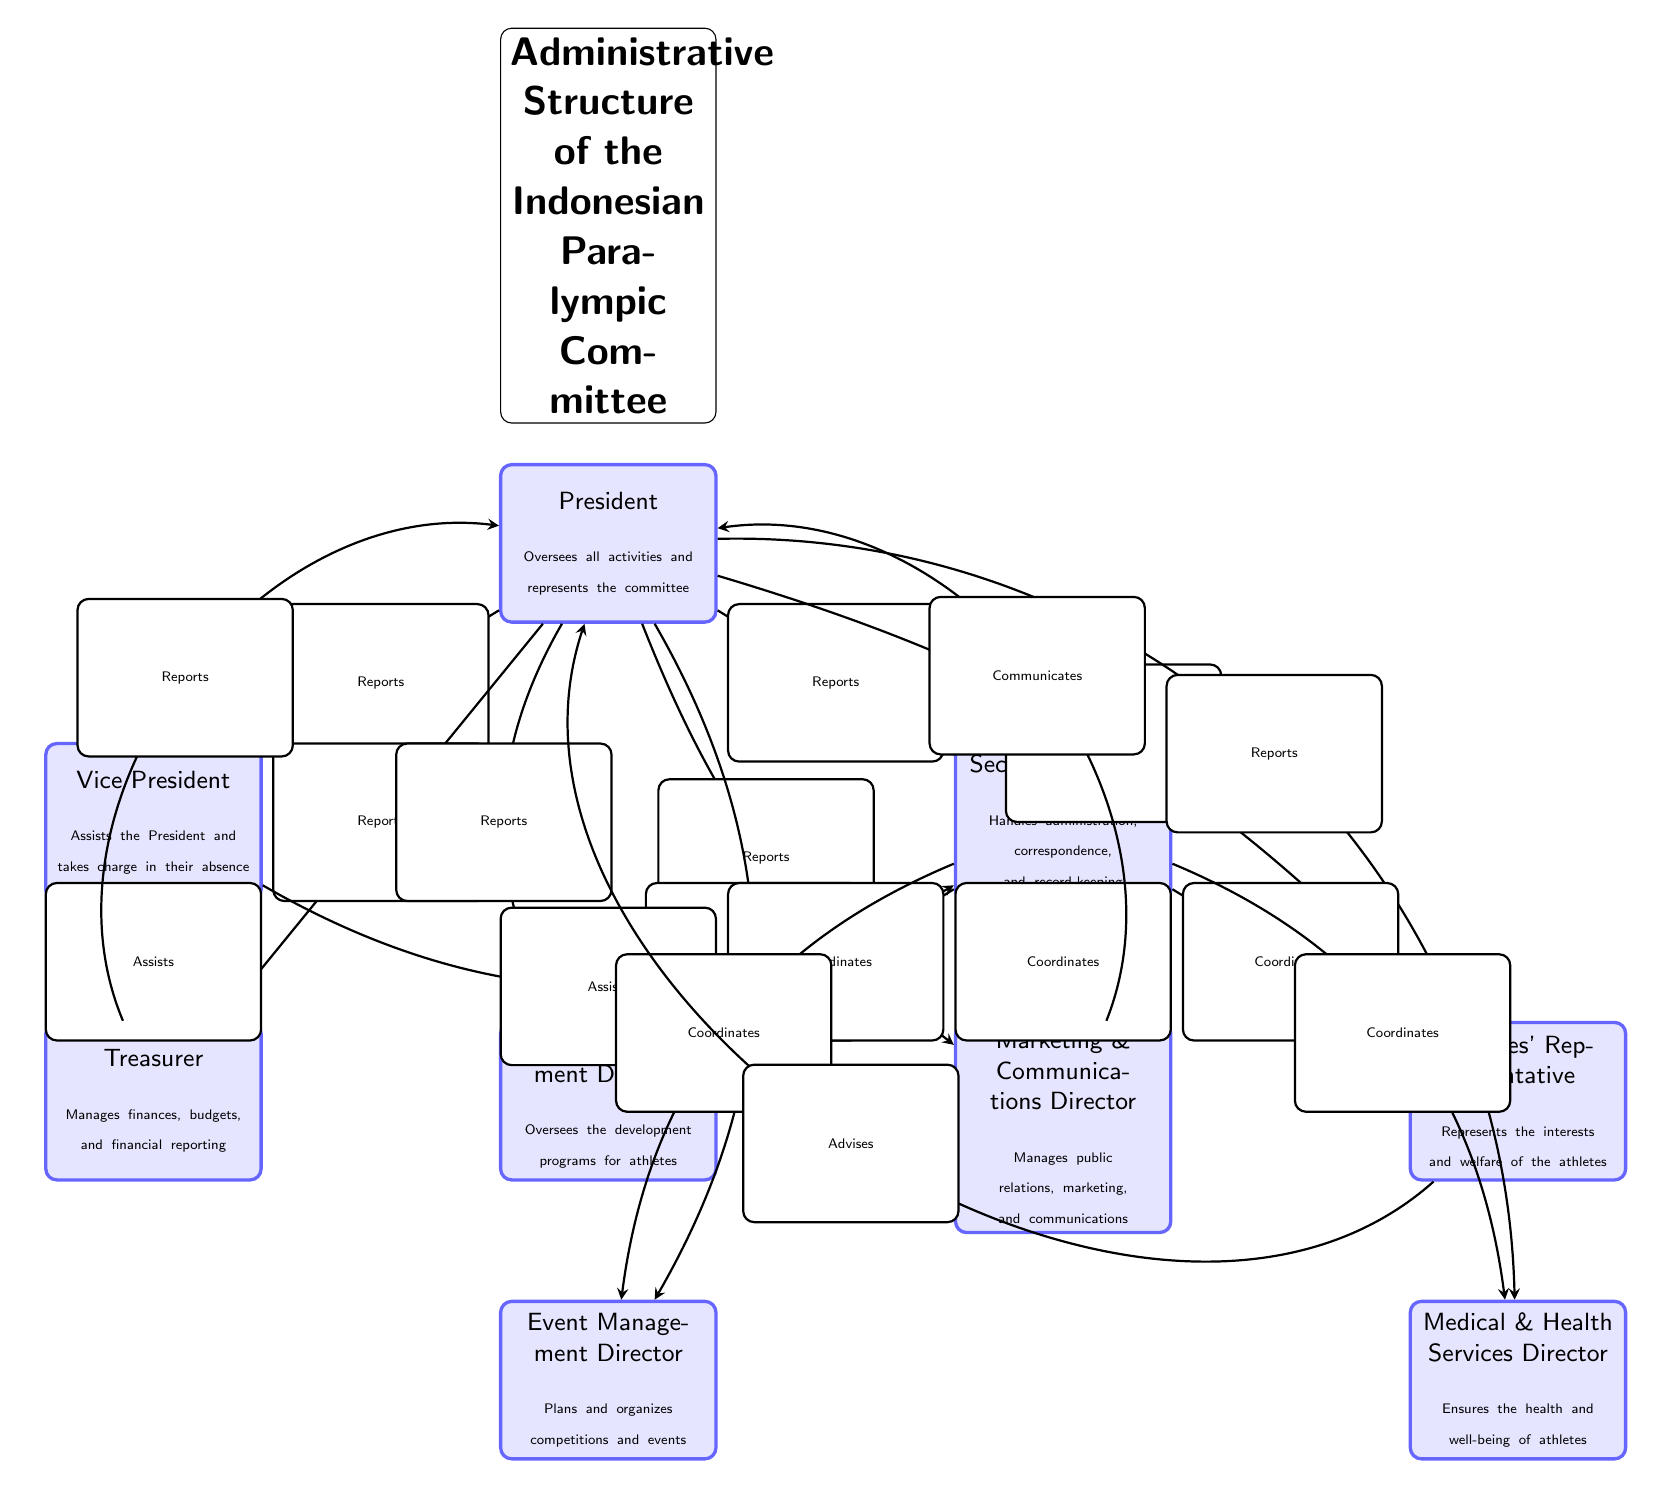What is the title of the diagram? The title of the diagram is explicitly stated above the nodes in the diagram, which indicates the subject being depicted.
Answer: Administrative Structure of the Indonesian Paralympic Committee How many main roles are represented in the diagram? The diagram clearly displays eight distinct roles, each represented by a separate node connected to the President.
Answer: 8 Who oversees all activities of the committee? The President node at the top of the diagram specifies this role, identifying the individual responsible for the overall supervision of the committee.
Answer: President What is the role of the Secretary General? The description of the Secretary General node defines the responsibilities associated with this position in the committee.
Answer: Handles administration, correspondence, and record-keeping Which position assists the President and takes charge in their absence? The node connected below the President that explicitly mentions assisting the President in their absence describes this role.
Answer: Vice President How does the Treasurer report their activities? The diagram shows that the Treasurer has a reporting line directed to the President, indicating how the Treasurer’s duties are communicated.
Answer: Reports to President Which role coordinates with the Athletes' Representative? The Secretary General node has a line connecting it to the Athletes' Representative node, indicating its coordination with this role.
Answer: Coordinates Which director ensures the health and well-being of athletes? The description below the Medical & Health Services Director node specifies the responsibilities of this role.
Answer: Medical & Health Services Director What is the relationship between the Vice President and the Secretary General? The diagram illustrates a line showing that the Vice President assists the Secretary General, establishing their working relationship.
Answer: Assists What type of diagram is this? The structure and labeling used within the diagram indicates it is a hierarchical representation of roles within an organization.
Answer: Textbook Diagram 